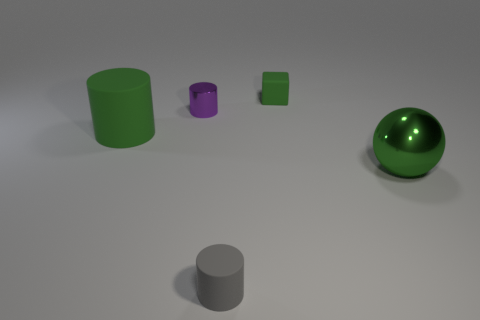There is a green thing that is on the left side of the green rubber thing behind the large object that is to the left of the purple cylinder; what is it made of?
Make the answer very short. Rubber. There is another cylinder that is made of the same material as the small gray cylinder; what is its size?
Ensure brevity in your answer.  Large. Is there any other thing that has the same color as the big sphere?
Offer a very short reply. Yes. There is a cylinder that is right of the purple metallic thing; is it the same color as the big object that is to the right of the gray matte object?
Keep it short and to the point. No. What is the color of the cylinder that is on the left side of the metal cylinder?
Offer a terse response. Green. Does the cylinder in front of the shiny sphere have the same size as the small purple cylinder?
Provide a succinct answer. Yes. Is the number of tiny yellow shiny balls less than the number of small gray rubber cylinders?
Provide a succinct answer. Yes. There is a big matte object that is the same color as the shiny sphere; what is its shape?
Offer a very short reply. Cylinder. What number of big things are left of the tiny metallic object?
Ensure brevity in your answer.  1. Do the large green rubber thing and the purple thing have the same shape?
Your answer should be compact. Yes. 